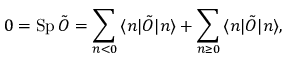<formula> <loc_0><loc_0><loc_500><loc_500>0 = S p \, \tilde { O } = \sum _ { n < 0 } \, \langle n | \tilde { O } | n \rangle + \sum _ { n \geq 0 } \, \langle n | \tilde { O } | n \rangle ,</formula> 